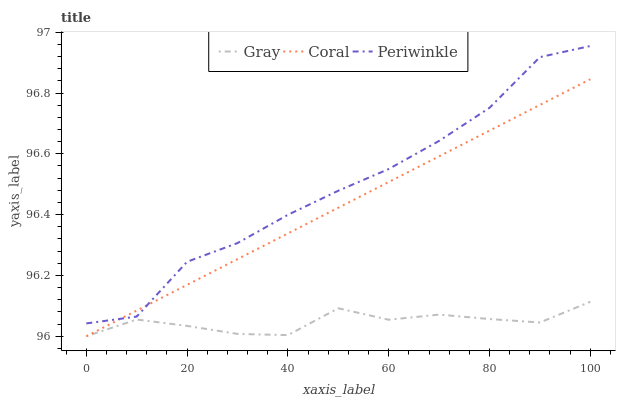Does Gray have the minimum area under the curve?
Answer yes or no. Yes. Does Periwinkle have the maximum area under the curve?
Answer yes or no. Yes. Does Coral have the minimum area under the curve?
Answer yes or no. No. Does Coral have the maximum area under the curve?
Answer yes or no. No. Is Coral the smoothest?
Answer yes or no. Yes. Is Periwinkle the roughest?
Answer yes or no. Yes. Is Periwinkle the smoothest?
Answer yes or no. No. Is Coral the roughest?
Answer yes or no. No. Does Gray have the lowest value?
Answer yes or no. Yes. Does Periwinkle have the lowest value?
Answer yes or no. No. Does Periwinkle have the highest value?
Answer yes or no. Yes. Does Coral have the highest value?
Answer yes or no. No. Is Gray less than Periwinkle?
Answer yes or no. Yes. Is Periwinkle greater than Gray?
Answer yes or no. Yes. Does Coral intersect Gray?
Answer yes or no. Yes. Is Coral less than Gray?
Answer yes or no. No. Is Coral greater than Gray?
Answer yes or no. No. Does Gray intersect Periwinkle?
Answer yes or no. No. 